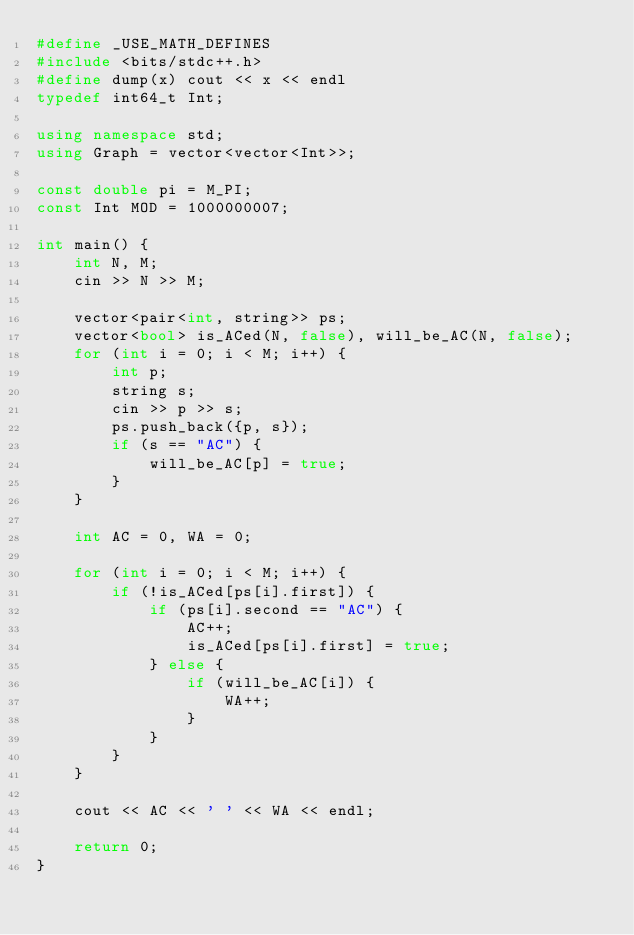<code> <loc_0><loc_0><loc_500><loc_500><_C++_>#define _USE_MATH_DEFINES
#include <bits/stdc++.h>
#define dump(x) cout << x << endl
typedef int64_t Int;

using namespace std;
using Graph = vector<vector<Int>>;

const double pi = M_PI;
const Int MOD = 1000000007;

int main() {
    int N, M;
    cin >> N >> M;

    vector<pair<int, string>> ps;
    vector<bool> is_ACed(N, false), will_be_AC(N, false);
    for (int i = 0; i < M; i++) {
        int p;
        string s;
        cin >> p >> s;
        ps.push_back({p, s});
        if (s == "AC") {
            will_be_AC[p] = true;
        }
    }

    int AC = 0, WA = 0;

    for (int i = 0; i < M; i++) {
        if (!is_ACed[ps[i].first]) {
            if (ps[i].second == "AC") {
                AC++;
                is_ACed[ps[i].first] = true;
            } else {
                if (will_be_AC[i]) {
                    WA++;
                }
            }
        }
    }

    cout << AC << ' ' << WA << endl;

    return 0;
}</code> 